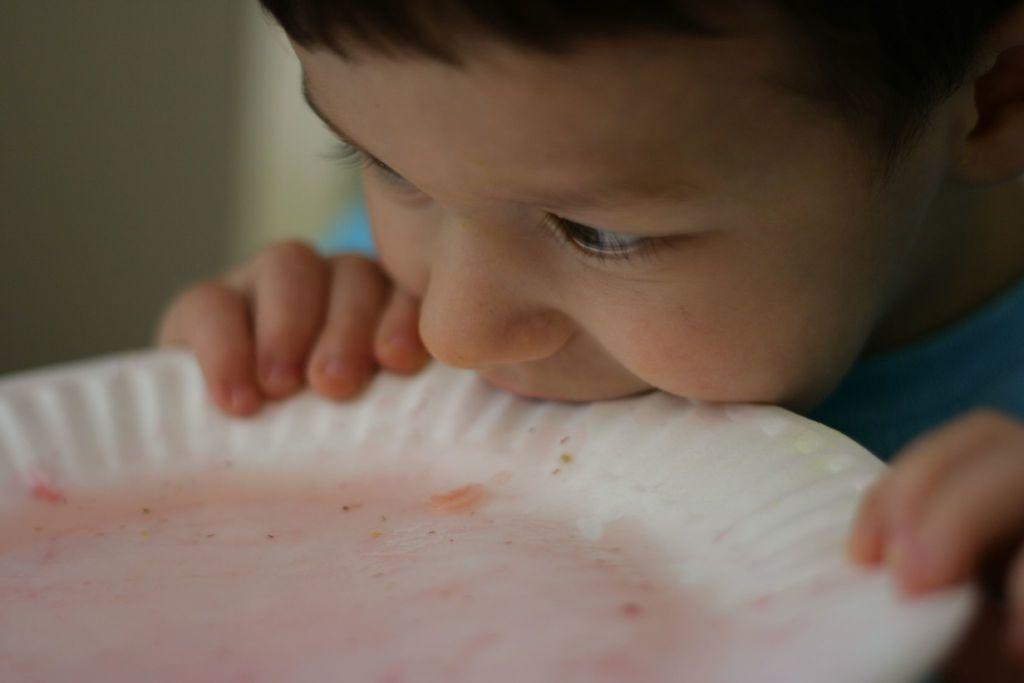Who is the main subject in the image? There is a boy in the image. What is the boy holding in the image? The boy is holding a plate in the image. How is the boy interacting with the plate? The boy is keeping the plate in his mouth. What can be observed about the background of the image? The background of the image has black and white colors. What is the rate of the powder falling from the boy's mouth in the image? There is no powder present in the image, so it is not possible to determine the rate at which it might be falling. 